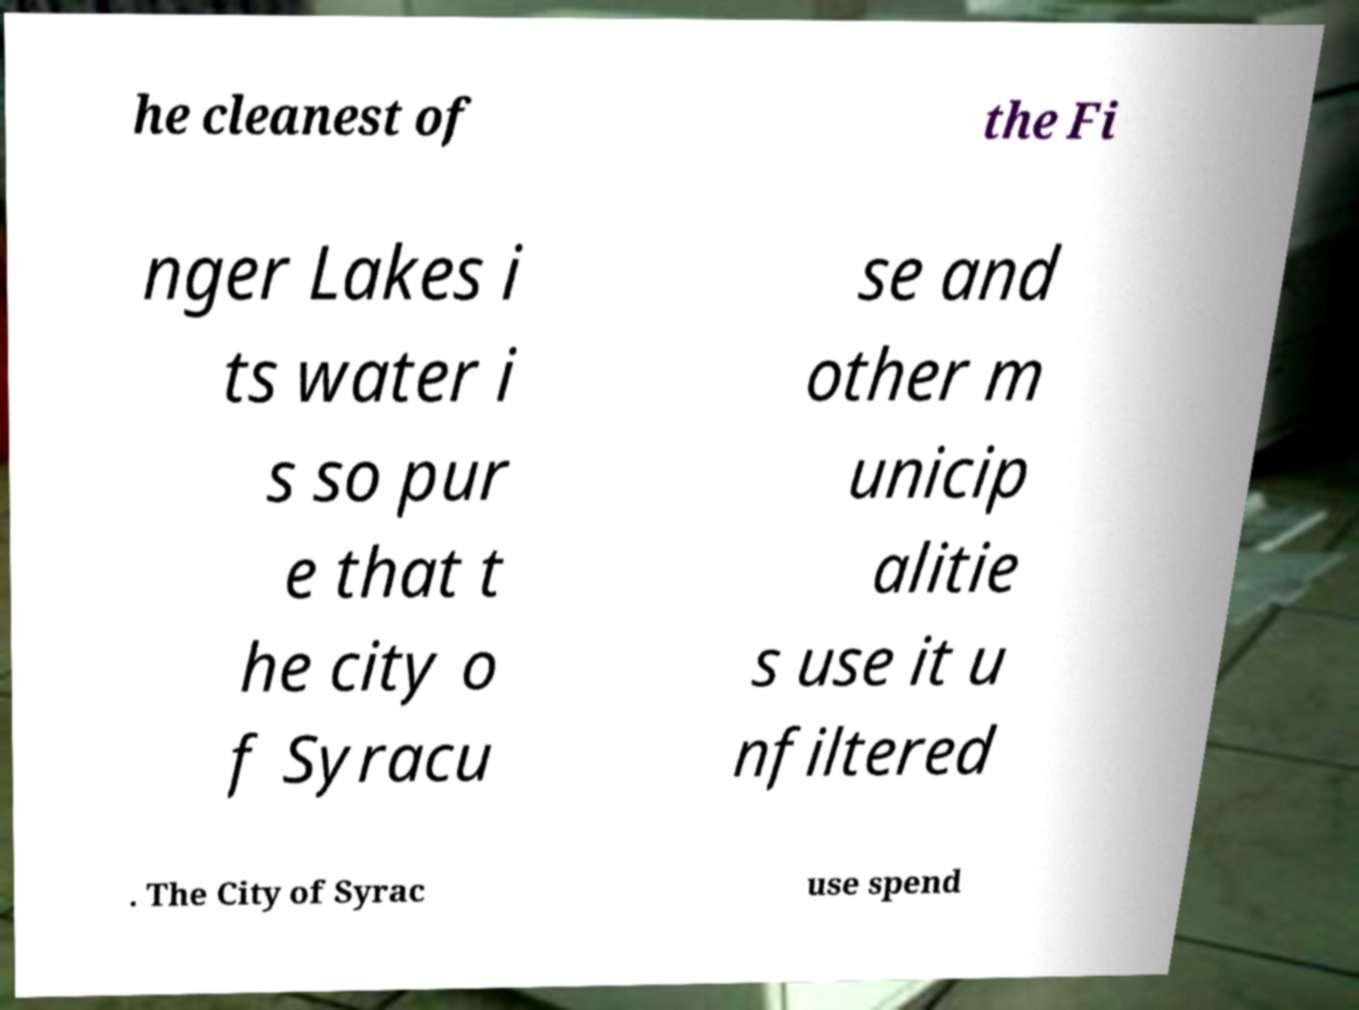Can you accurately transcribe the text from the provided image for me? he cleanest of the Fi nger Lakes i ts water i s so pur e that t he city o f Syracu se and other m unicip alitie s use it u nfiltered . The City of Syrac use spend 